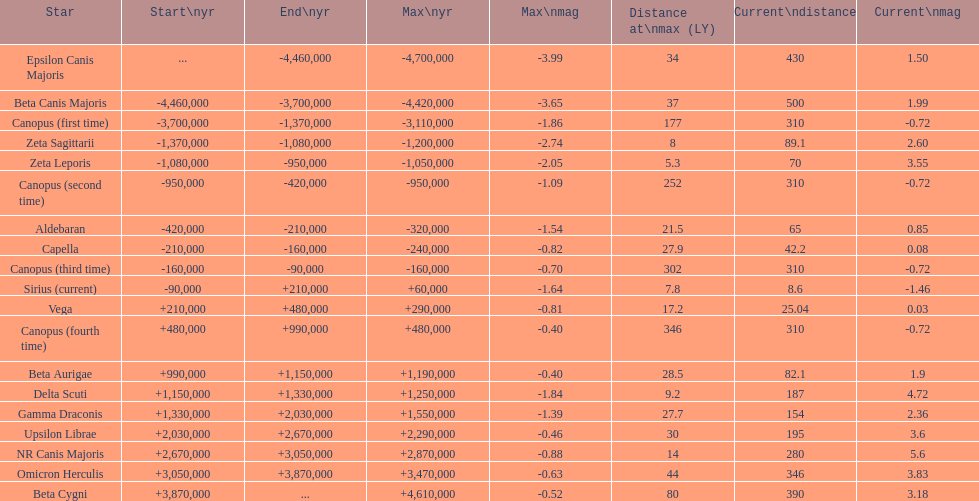What is the only star with a distance at maximum of 80? Beta Cygni. 